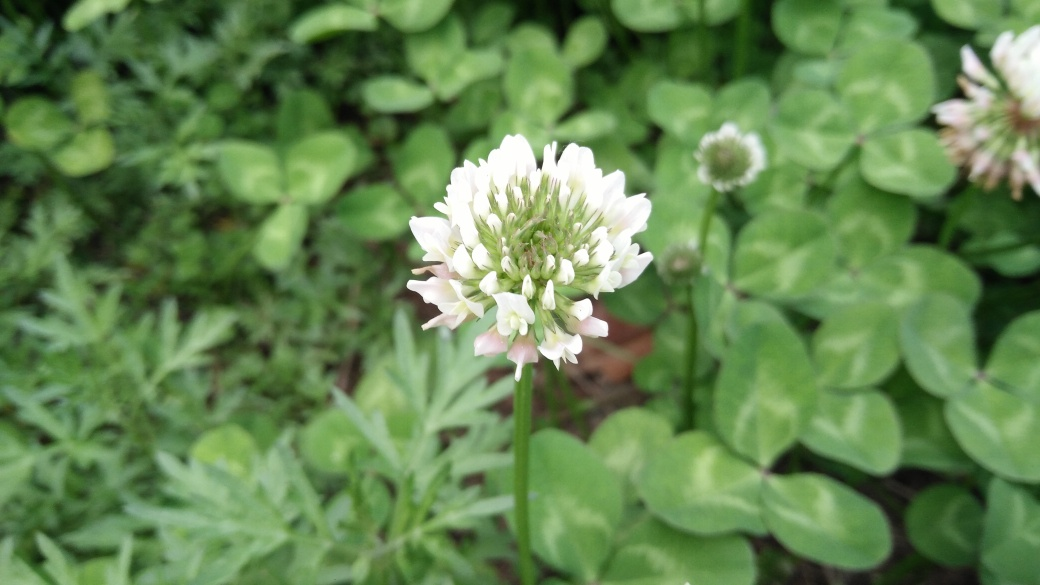Are the green leaves sharp?
A. No
B. Yes
Answer with the option's letter from the given choices directly. The green leaves in the image appear to be lush and healthy, without any evident sharpness or spiky edges. The leaves belong to a ground cover plant which typically has soft, non-aggressive foliage. Hence, the answer is A: No, the green leaves are not sharp. 